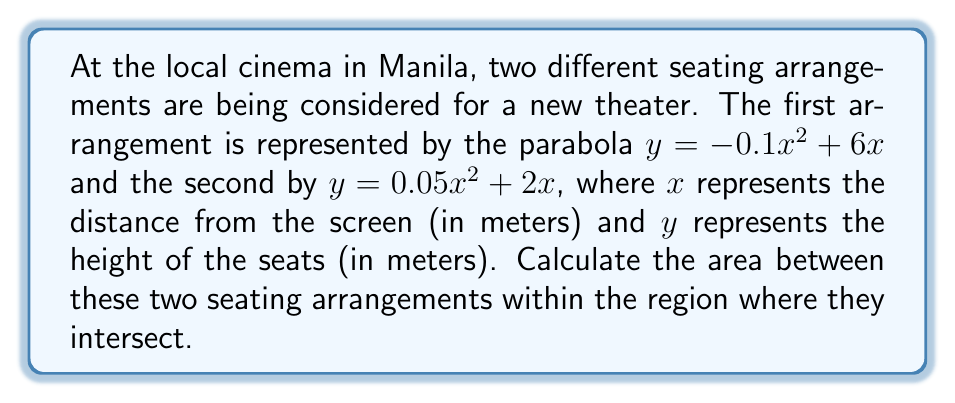Provide a solution to this math problem. Let's approach this step-by-step:

1) First, we need to find the points of intersection. We set the equations equal to each other:

   $-0.1x^2 + 6x = 0.05x^2 + 2x$

2) Rearranging the terms:

   $-0.15x^2 + 4x = 0$

3) Factoring out x:

   $x(-0.15x + 4) = 0$

4) Solving for x:

   $x = 0$ or $x = \frac{4}{0.15} = \frac{80}{3} \approx 26.67$

5) The parabolas intersect at $x = 0$ and $x = \frac{80}{3}$.

6) To find the area between the curves, we need to integrate the difference of the functions from $x = 0$ to $x = \frac{80}{3}$:

   $$A = \int_0^{\frac{80}{3}} [(0.05x^2 + 2x) - (-0.1x^2 + 6x)] dx$$

7) Simplifying the integrand:

   $$A = \int_0^{\frac{80}{3}} (0.15x^2 - 4x) dx$$

8) Integrating:

   $$A = [\frac{0.15x^3}{3} - 2x^2]_0^{\frac{80}{3}}$$

9) Evaluating the integral:

   $$A = [\frac{0.15(\frac{80}{3})^3}{3} - 2(\frac{80}{3})^2] - [0 - 0]$$

10) Simplifying:

    $$A = \frac{0.15 \cdot 512000}{81} - \frac{12800}{9} = \frac{76800}{81} - \frac{12800}{9} = \frac{76800 - 115200}{81} = -\frac{38400}{81}$$

11) The negative sign indicates that we integrated in the wrong direction. The actual area is the absolute value of this result.

    $$A = |\frac{38400}{81}| = \frac{38400}{81} \approx 473.83 \text{ square meters}$$
Answer: $\frac{38400}{81}$ square meters 